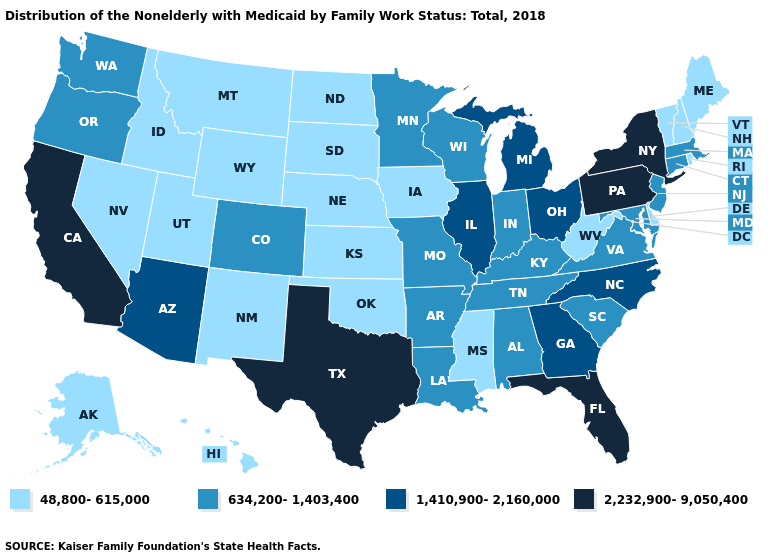Among the states that border Delaware , does Maryland have the lowest value?
Be succinct. Yes. How many symbols are there in the legend?
Write a very short answer. 4. Does Wisconsin have a higher value than Alabama?
Concise answer only. No. Does Georgia have the highest value in the South?
Write a very short answer. No. What is the highest value in the MidWest ?
Answer briefly. 1,410,900-2,160,000. Name the states that have a value in the range 2,232,900-9,050,400?
Write a very short answer. California, Florida, New York, Pennsylvania, Texas. Name the states that have a value in the range 2,232,900-9,050,400?
Write a very short answer. California, Florida, New York, Pennsylvania, Texas. Name the states that have a value in the range 1,410,900-2,160,000?
Concise answer only. Arizona, Georgia, Illinois, Michigan, North Carolina, Ohio. Among the states that border Alabama , which have the lowest value?
Concise answer only. Mississippi. Name the states that have a value in the range 48,800-615,000?
Concise answer only. Alaska, Delaware, Hawaii, Idaho, Iowa, Kansas, Maine, Mississippi, Montana, Nebraska, Nevada, New Hampshire, New Mexico, North Dakota, Oklahoma, Rhode Island, South Dakota, Utah, Vermont, West Virginia, Wyoming. Among the states that border Idaho , does Nevada have the lowest value?
Write a very short answer. Yes. Does the first symbol in the legend represent the smallest category?
Give a very brief answer. Yes. Does Arkansas have the same value as Alabama?
Concise answer only. Yes. Name the states that have a value in the range 634,200-1,403,400?
Short answer required. Alabama, Arkansas, Colorado, Connecticut, Indiana, Kentucky, Louisiana, Maryland, Massachusetts, Minnesota, Missouri, New Jersey, Oregon, South Carolina, Tennessee, Virginia, Washington, Wisconsin. What is the value of Oregon?
Answer briefly. 634,200-1,403,400. 